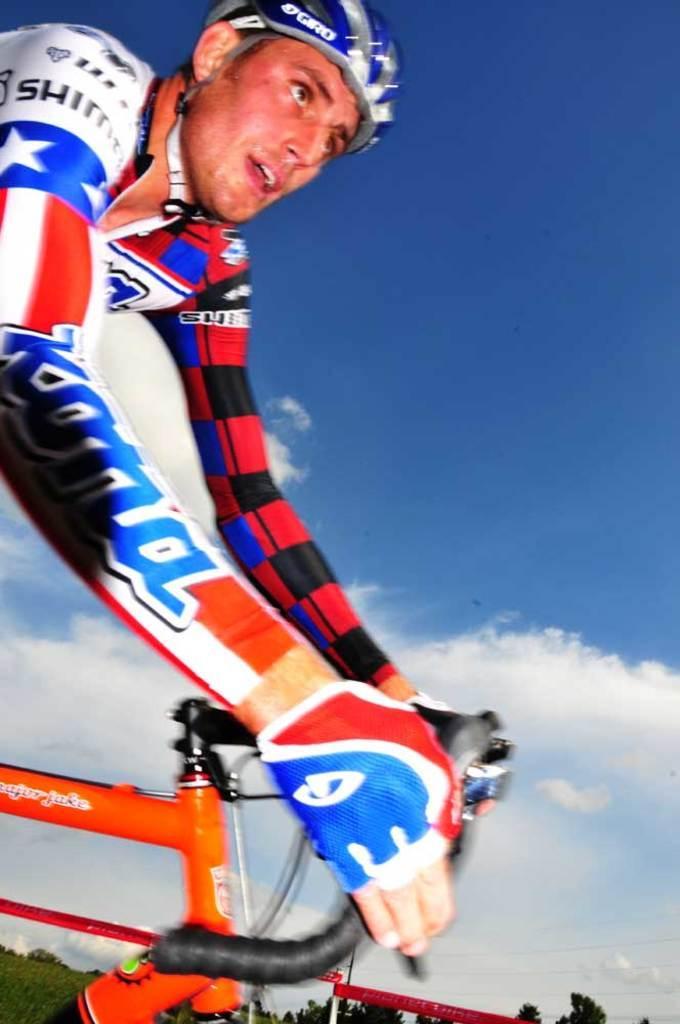Can you describe this image briefly? In this picture, there is a man riding a bicycle. He is wearing a helmet. In the background, there is a sky with clouds. At the bottom, there are trees. 